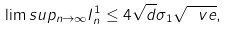<formula> <loc_0><loc_0><loc_500><loc_500>\lim s u p _ { n \to \infty } I ^ { 1 } _ { n } \leq 4 \sqrt { d } \sigma _ { 1 } \sqrt { \ v e } ,</formula> 